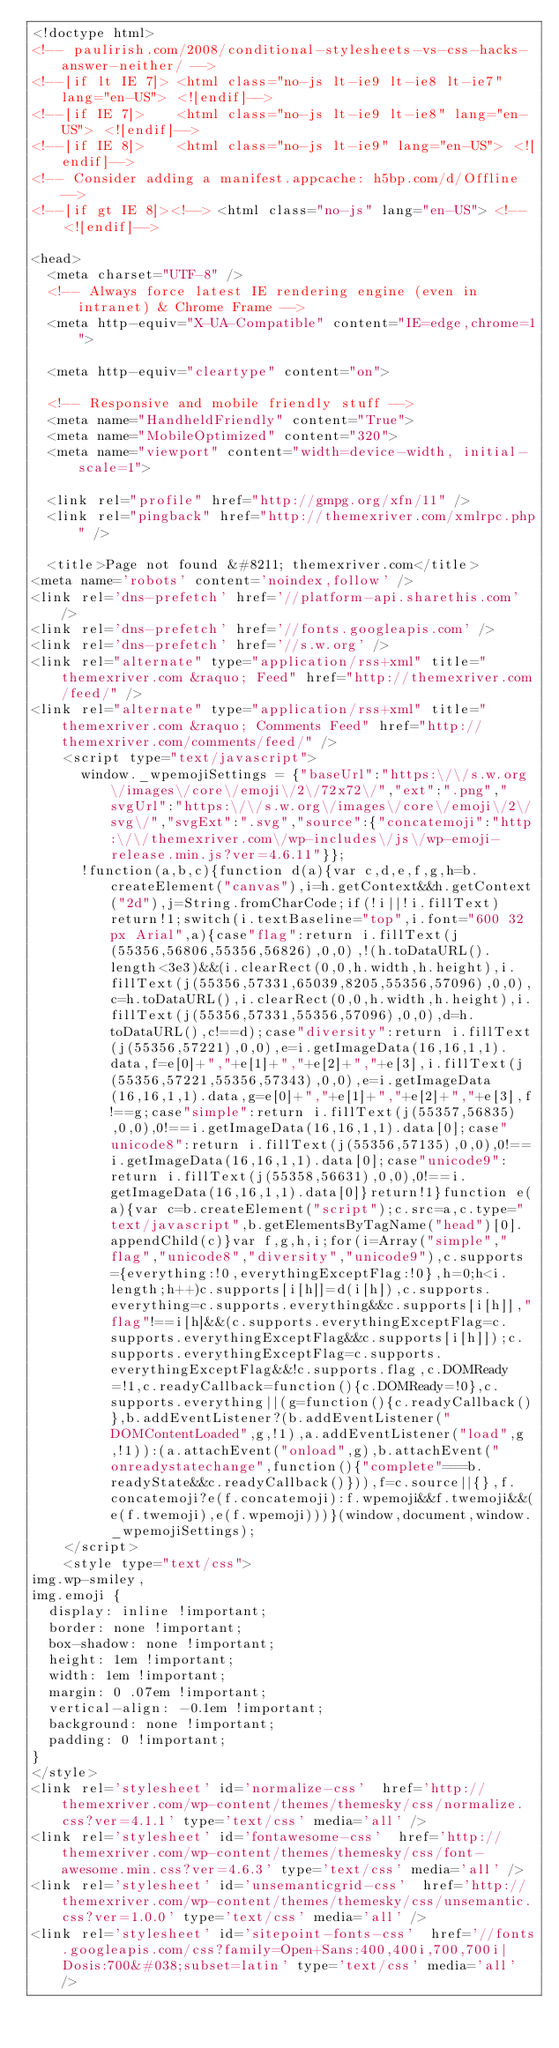Convert code to text. <code><loc_0><loc_0><loc_500><loc_500><_HTML_><!doctype html>
<!-- paulirish.com/2008/conditional-stylesheets-vs-css-hacks-answer-neither/ -->
<!--[if lt IE 7]> <html class="no-js lt-ie9 lt-ie8 lt-ie7" lang="en-US"> <![endif]-->
<!--[if IE 7]>    <html class="no-js lt-ie9 lt-ie8" lang="en-US"> <![endif]-->
<!--[if IE 8]>    <html class="no-js lt-ie9" lang="en-US"> <![endif]-->
<!-- Consider adding a manifest.appcache: h5bp.com/d/Offline -->
<!--[if gt IE 8]><!--> <html class="no-js" lang="en-US"> <!--<![endif]-->

<head>
	<meta charset="UTF-8" />
	<!-- Always force latest IE rendering engine (even in intranet) & Chrome Frame -->
	<meta http-equiv="X-UA-Compatible" content="IE=edge,chrome=1">

	<meta http-equiv="cleartype" content="on">

	<!-- Responsive and mobile friendly stuff -->
	<meta name="HandheldFriendly" content="True">
	<meta name="MobileOptimized" content="320">
	<meta name="viewport" content="width=device-width, initial-scale=1">

	<link rel="profile" href="http://gmpg.org/xfn/11" />
	<link rel="pingback" href="http://themexriver.com/xmlrpc.php" />

	<title>Page not found &#8211; themexriver.com</title>
<meta name='robots' content='noindex,follow' />
<link rel='dns-prefetch' href='//platform-api.sharethis.com' />
<link rel='dns-prefetch' href='//fonts.googleapis.com' />
<link rel='dns-prefetch' href='//s.w.org' />
<link rel="alternate" type="application/rss+xml" title="themexriver.com &raquo; Feed" href="http://themexriver.com/feed/" />
<link rel="alternate" type="application/rss+xml" title="themexriver.com &raquo; Comments Feed" href="http://themexriver.com/comments/feed/" />
		<script type="text/javascript">
			window._wpemojiSettings = {"baseUrl":"https:\/\/s.w.org\/images\/core\/emoji\/2\/72x72\/","ext":".png","svgUrl":"https:\/\/s.w.org\/images\/core\/emoji\/2\/svg\/","svgExt":".svg","source":{"concatemoji":"http:\/\/themexriver.com\/wp-includes\/js\/wp-emoji-release.min.js?ver=4.6.11"}};
			!function(a,b,c){function d(a){var c,d,e,f,g,h=b.createElement("canvas"),i=h.getContext&&h.getContext("2d"),j=String.fromCharCode;if(!i||!i.fillText)return!1;switch(i.textBaseline="top",i.font="600 32px Arial",a){case"flag":return i.fillText(j(55356,56806,55356,56826),0,0),!(h.toDataURL().length<3e3)&&(i.clearRect(0,0,h.width,h.height),i.fillText(j(55356,57331,65039,8205,55356,57096),0,0),c=h.toDataURL(),i.clearRect(0,0,h.width,h.height),i.fillText(j(55356,57331,55356,57096),0,0),d=h.toDataURL(),c!==d);case"diversity":return i.fillText(j(55356,57221),0,0),e=i.getImageData(16,16,1,1).data,f=e[0]+","+e[1]+","+e[2]+","+e[3],i.fillText(j(55356,57221,55356,57343),0,0),e=i.getImageData(16,16,1,1).data,g=e[0]+","+e[1]+","+e[2]+","+e[3],f!==g;case"simple":return i.fillText(j(55357,56835),0,0),0!==i.getImageData(16,16,1,1).data[0];case"unicode8":return i.fillText(j(55356,57135),0,0),0!==i.getImageData(16,16,1,1).data[0];case"unicode9":return i.fillText(j(55358,56631),0,0),0!==i.getImageData(16,16,1,1).data[0]}return!1}function e(a){var c=b.createElement("script");c.src=a,c.type="text/javascript",b.getElementsByTagName("head")[0].appendChild(c)}var f,g,h,i;for(i=Array("simple","flag","unicode8","diversity","unicode9"),c.supports={everything:!0,everythingExceptFlag:!0},h=0;h<i.length;h++)c.supports[i[h]]=d(i[h]),c.supports.everything=c.supports.everything&&c.supports[i[h]],"flag"!==i[h]&&(c.supports.everythingExceptFlag=c.supports.everythingExceptFlag&&c.supports[i[h]]);c.supports.everythingExceptFlag=c.supports.everythingExceptFlag&&!c.supports.flag,c.DOMReady=!1,c.readyCallback=function(){c.DOMReady=!0},c.supports.everything||(g=function(){c.readyCallback()},b.addEventListener?(b.addEventListener("DOMContentLoaded",g,!1),a.addEventListener("load",g,!1)):(a.attachEvent("onload",g),b.attachEvent("onreadystatechange",function(){"complete"===b.readyState&&c.readyCallback()})),f=c.source||{},f.concatemoji?e(f.concatemoji):f.wpemoji&&f.twemoji&&(e(f.twemoji),e(f.wpemoji)))}(window,document,window._wpemojiSettings);
		</script>
		<style type="text/css">
img.wp-smiley,
img.emoji {
	display: inline !important;
	border: none !important;
	box-shadow: none !important;
	height: 1em !important;
	width: 1em !important;
	margin: 0 .07em !important;
	vertical-align: -0.1em !important;
	background: none !important;
	padding: 0 !important;
}
</style>
<link rel='stylesheet' id='normalize-css'  href='http://themexriver.com/wp-content/themes/themesky/css/normalize.css?ver=4.1.1' type='text/css' media='all' />
<link rel='stylesheet' id='fontawesome-css'  href='http://themexriver.com/wp-content/themes/themesky/css/font-awesome.min.css?ver=4.6.3' type='text/css' media='all' />
<link rel='stylesheet' id='unsemanticgrid-css'  href='http://themexriver.com/wp-content/themes/themesky/css/unsemantic.css?ver=1.0.0' type='text/css' media='all' />
<link rel='stylesheet' id='sitepoint-fonts-css'  href='//fonts.googleapis.com/css?family=Open+Sans:400,400i,700,700i|Dosis:700&#038;subset=latin' type='text/css' media='all' /></code> 